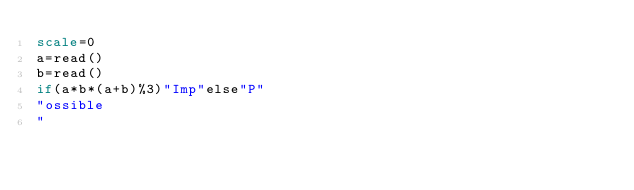<code> <loc_0><loc_0><loc_500><loc_500><_bc_>scale=0
a=read()
b=read()
if(a*b*(a+b)%3)"Imp"else"P"
"ossible
"
</code> 